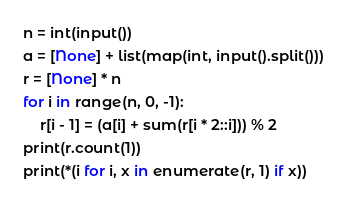Convert code to text. <code><loc_0><loc_0><loc_500><loc_500><_Python_>n = int(input())
a = [None] + list(map(int, input().split()))
r = [None] * n
for i in range(n, 0, -1):
    r[i - 1] = (a[i] + sum(r[i * 2::i])) % 2
print(r.count(1))
print(*(i for i, x in enumerate(r, 1) if x))
</code> 